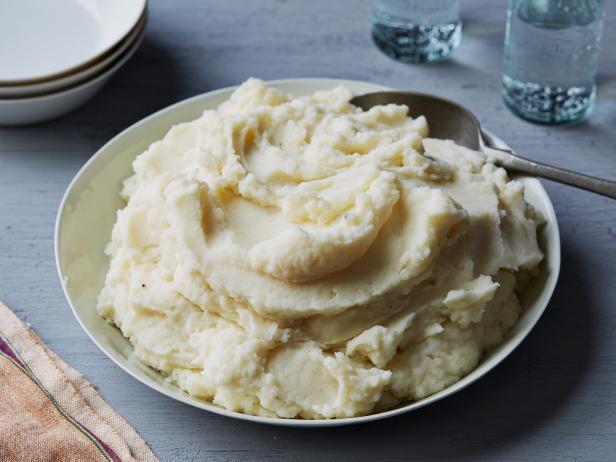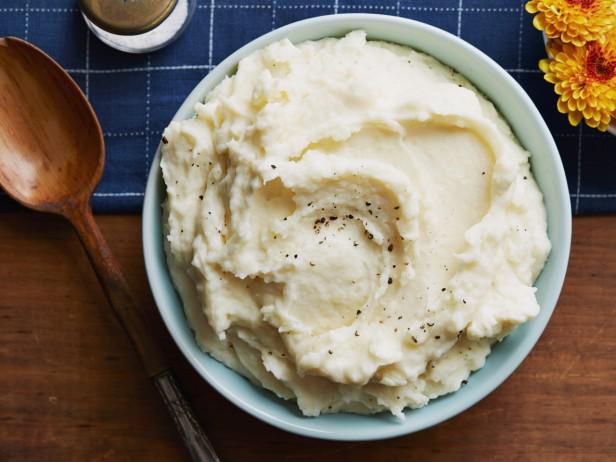The first image is the image on the left, the second image is the image on the right. For the images displayed, is the sentence "One image shows a bowl of mashed potatoes with no spoon near it." factually correct? Answer yes or no. No. 